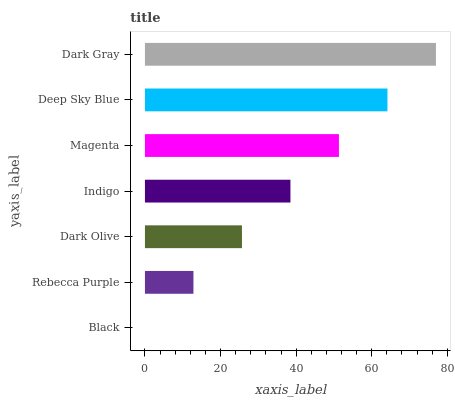Is Black the minimum?
Answer yes or no. Yes. Is Dark Gray the maximum?
Answer yes or no. Yes. Is Rebecca Purple the minimum?
Answer yes or no. No. Is Rebecca Purple the maximum?
Answer yes or no. No. Is Rebecca Purple greater than Black?
Answer yes or no. Yes. Is Black less than Rebecca Purple?
Answer yes or no. Yes. Is Black greater than Rebecca Purple?
Answer yes or no. No. Is Rebecca Purple less than Black?
Answer yes or no. No. Is Indigo the high median?
Answer yes or no. Yes. Is Indigo the low median?
Answer yes or no. Yes. Is Magenta the high median?
Answer yes or no. No. Is Dark Olive the low median?
Answer yes or no. No. 